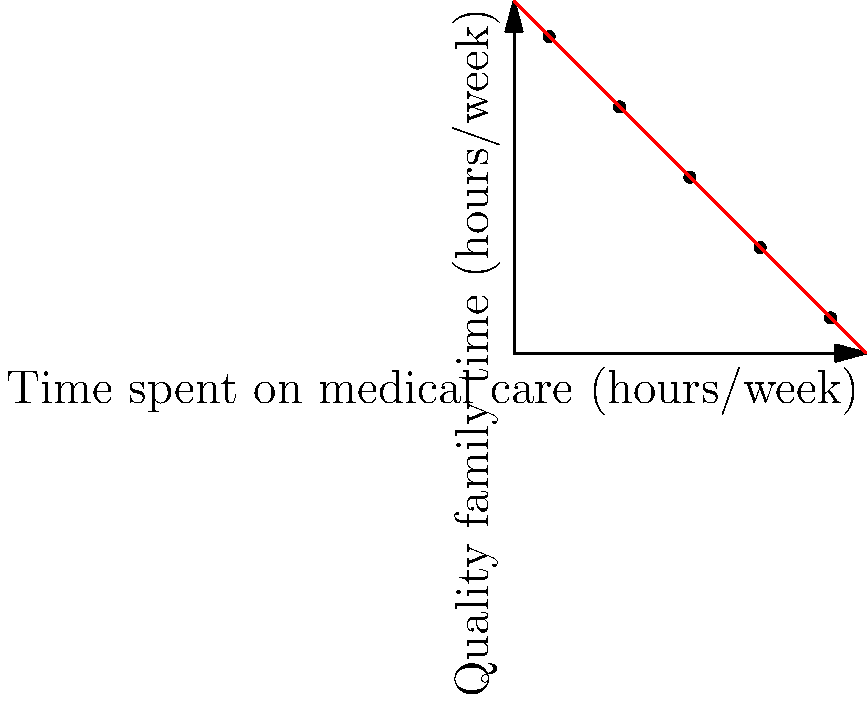Based on the scatter plot showing the relationship between time spent on medical care and quality family time for families with children with rare genetic disorders, what type of correlation is observed, and how might this impact a resilient father's approach to balancing care responsibilities? To answer this question, let's analyze the scatter plot step-by-step:

1. Observe the overall trend: As we move from left to right (increasing time spent on medical care), the points generally move downward (decreasing quality family time).

2. Identify the correlation type: This downward trend indicates a negative or inverse correlation between the two variables.

3. Assess the strength of the correlation: The points appear to form a fairly straight line, suggesting a strong linear relationship.

4. Interpret the relationship: As time spent on medical care increases, quality family time tends to decrease proportionally.

5. Calculate the correlation coefficient: While we don't have the exact data, visually, this appears to be close to a perfect negative correlation (r ≈ -1).

6. Consider the impact on a resilient father:
   a. Recognize the challenge: Increasing medical care time may lead to decreased family time.
   b. Seek balance: Find ways to integrate quality family moments into medical care routines.
   c. Optimize care efficiency: Look for ways to streamline medical care to free up more family time.
   d. Prioritize self-care: Ensure personal well-being to maintain resilience in facing this challenge.

7. Practical implications:
   a. Schedule dedicated family time, even if brief.
   b. Involve family members in care routines when appropriate.
   c. Utilize respite care or support systems to create more family time.
   d. Focus on the quality of interactions rather than just quantity of time.
Answer: Strong negative correlation; balance care and family time 